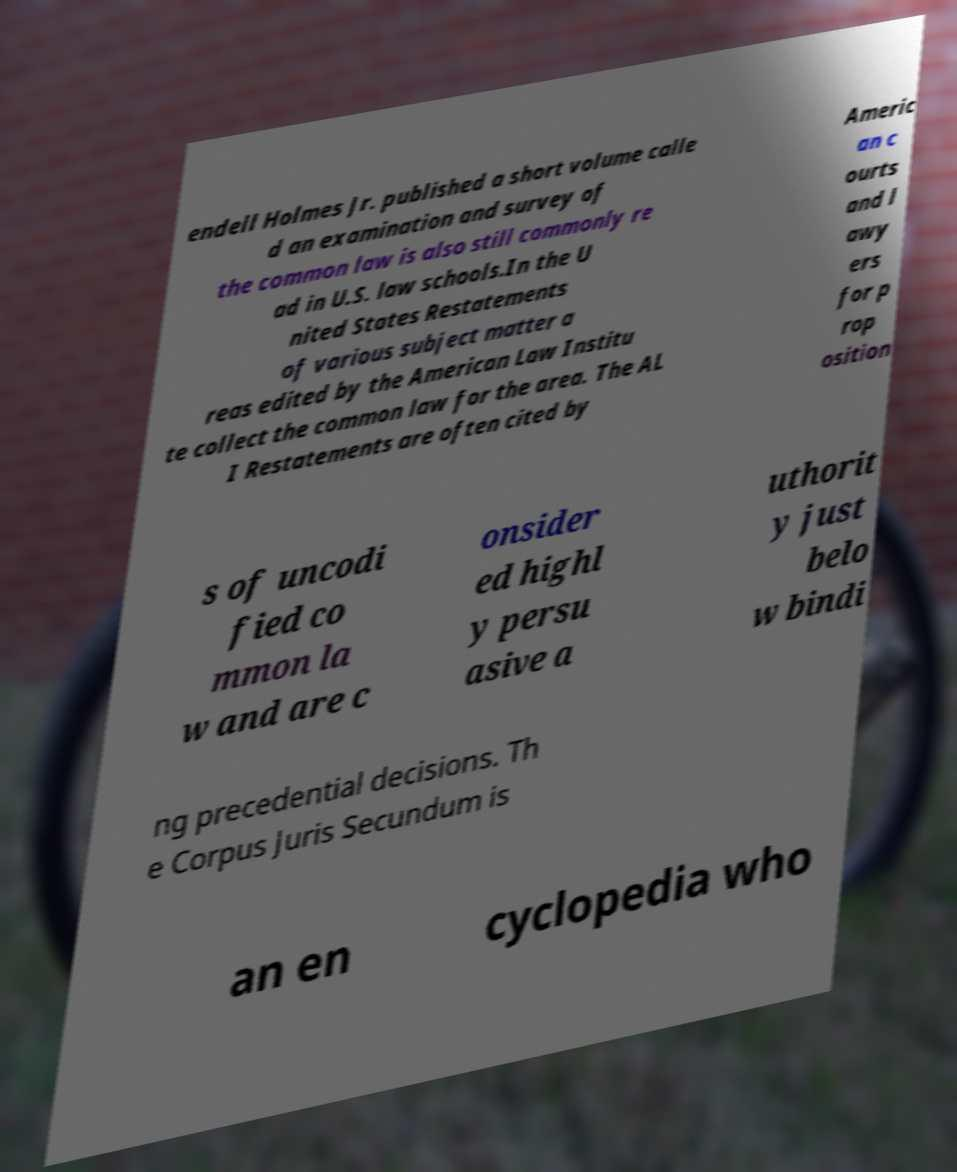What messages or text are displayed in this image? I need them in a readable, typed format. endell Holmes Jr. published a short volume calle d an examination and survey of the common law is also still commonly re ad in U.S. law schools.In the U nited States Restatements of various subject matter a reas edited by the American Law Institu te collect the common law for the area. The AL I Restatements are often cited by Americ an c ourts and l awy ers for p rop osition s of uncodi fied co mmon la w and are c onsider ed highl y persu asive a uthorit y just belo w bindi ng precedential decisions. Th e Corpus Juris Secundum is an en cyclopedia who 